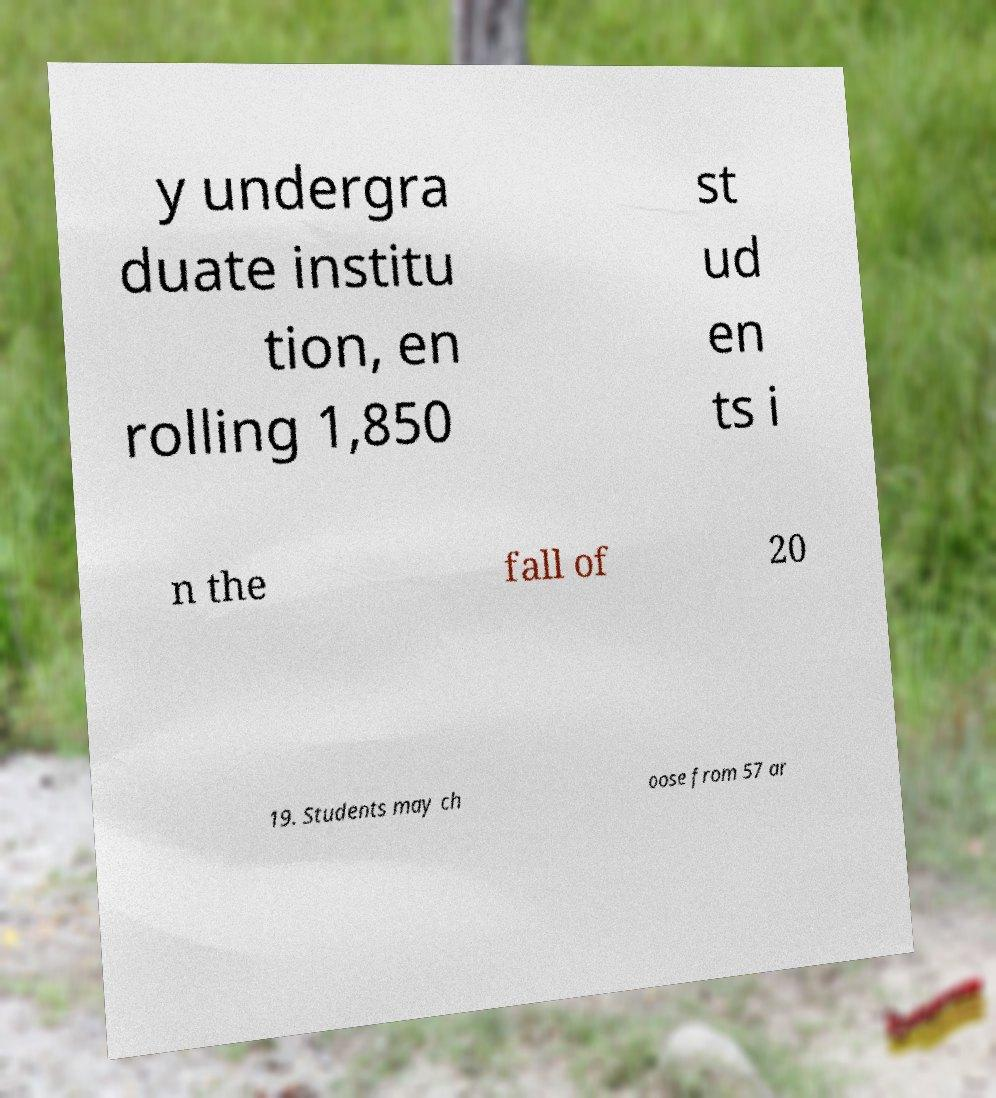Can you accurately transcribe the text from the provided image for me? y undergra duate institu tion, en rolling 1,850 st ud en ts i n the fall of 20 19. Students may ch oose from 57 ar 